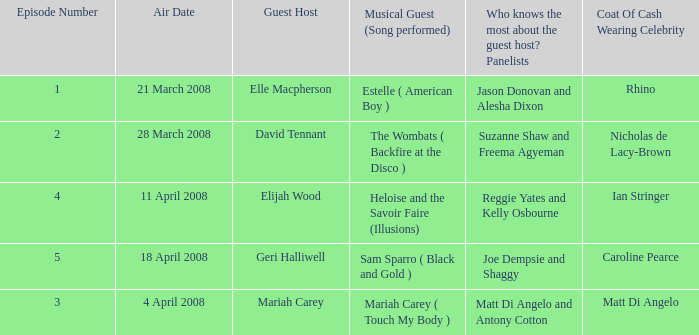Name the number of panelists for oat of cash wearing celebrity being matt di angelo 1.0. 